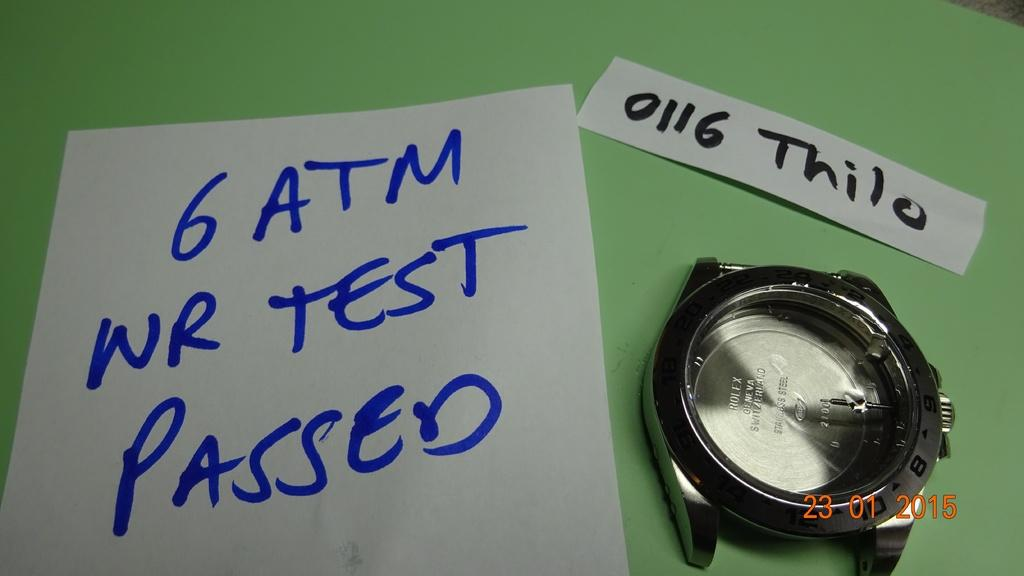<image>
Create a compact narrative representing the image presented. A note is on a green surface next to a watch and the note indicates a test was passed. 